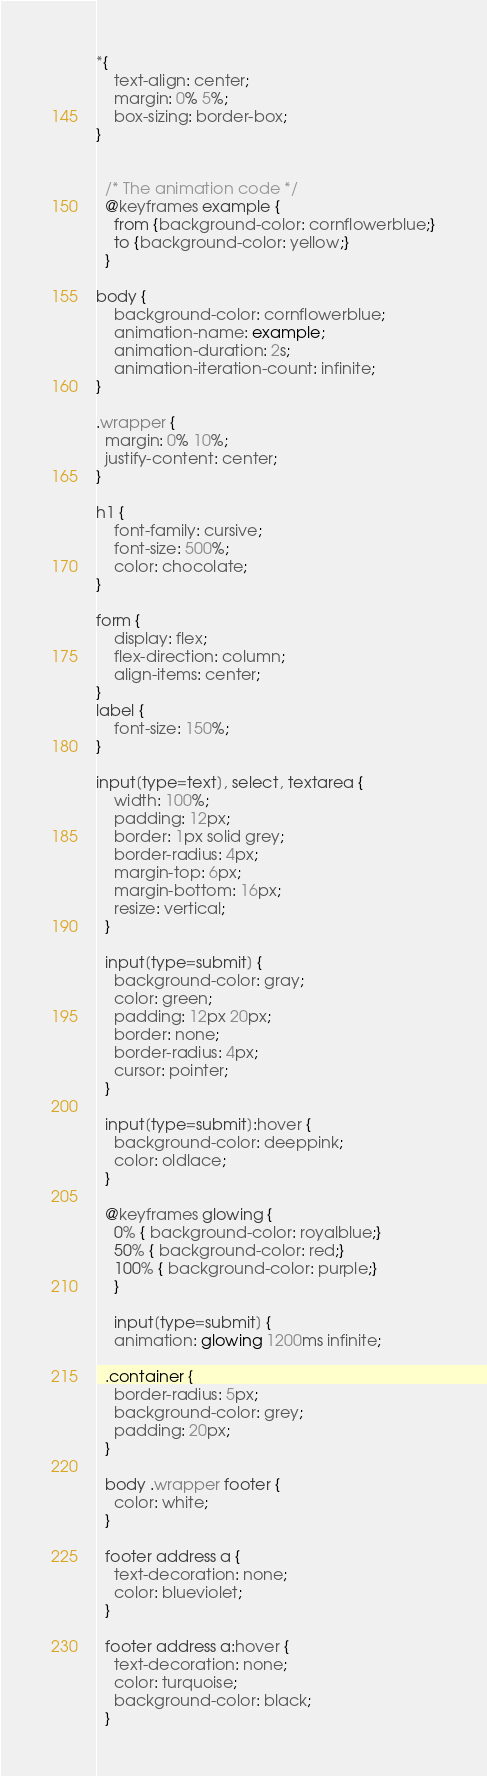<code> <loc_0><loc_0><loc_500><loc_500><_CSS_>*{
    text-align: center;
    margin: 0% 5%;
    box-sizing: border-box; 
}


  /* The animation code */
  @keyframes example {
    from {background-color: cornflowerblue;}
    to {background-color: yellow;}
  }
  
body {
    background-color: cornflowerblue;
    animation-name: example;
    animation-duration: 2s;
    animation-iteration-count: infinite;
}

.wrapper {
  margin: 0% 10%;
  justify-content: center;
}

h1 {
    font-family: cursive;
    font-size: 500%;
    color: chocolate;
}

form {
    display: flex;
    flex-direction: column;
    align-items: center;
}
label {
    font-size: 150%;
}

input[type=text], select, textarea {
    width: 100%; 
    padding: 12px; 
    border: 1px solid grey;
    border-radius: 4px;    
    margin-top: 6px; 
    margin-bottom: 16px; 
    resize: vertical; 
  }
  
  input[type=submit] {
    background-color: gray;
    color: green;
    padding: 12px 20px;
    border: none;
    border-radius: 4px;
    cursor: pointer;
  }
  
  input[type=submit]:hover {
    background-color: deeppink;
    color: oldlace;
  }

  @keyframes glowing {
    0% { background-color: royalblue;}
    50% { background-color: red;}
    100% { background-color: purple;}
    }

    input[type=submit] {
    animation: glowing 1200ms infinite;
  
  .container {
    border-radius: 5px;
    background-color: grey;
    padding: 20px;
  }

  body .wrapper footer {
    color: white;
  }

  footer address a {
    text-decoration: none;
    color: blueviolet;
  }

  footer address a:hover {
    text-decoration: none;
    color: turquoise;
    background-color: black;
  }




</code> 